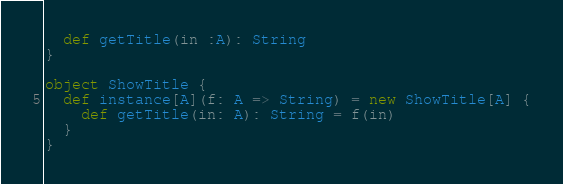<code> <loc_0><loc_0><loc_500><loc_500><_Scala_>  def getTitle(in :A): String
}

object ShowTitle {
  def instance[A](f: A => String) = new ShowTitle[A] {
    def getTitle(in: A): String = f(in)
  }
}
</code> 